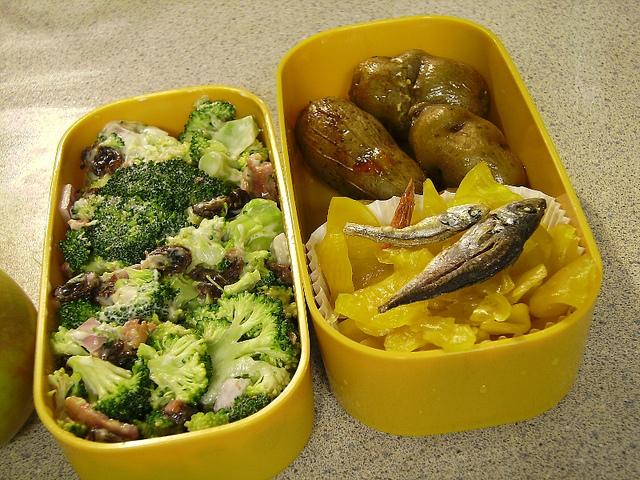Are there fish in the picture?
Answer briefly. Yes. What is the green vegetable called?
Concise answer only. Broccoli. What color are the food containers?
Short answer required. Yellow. 